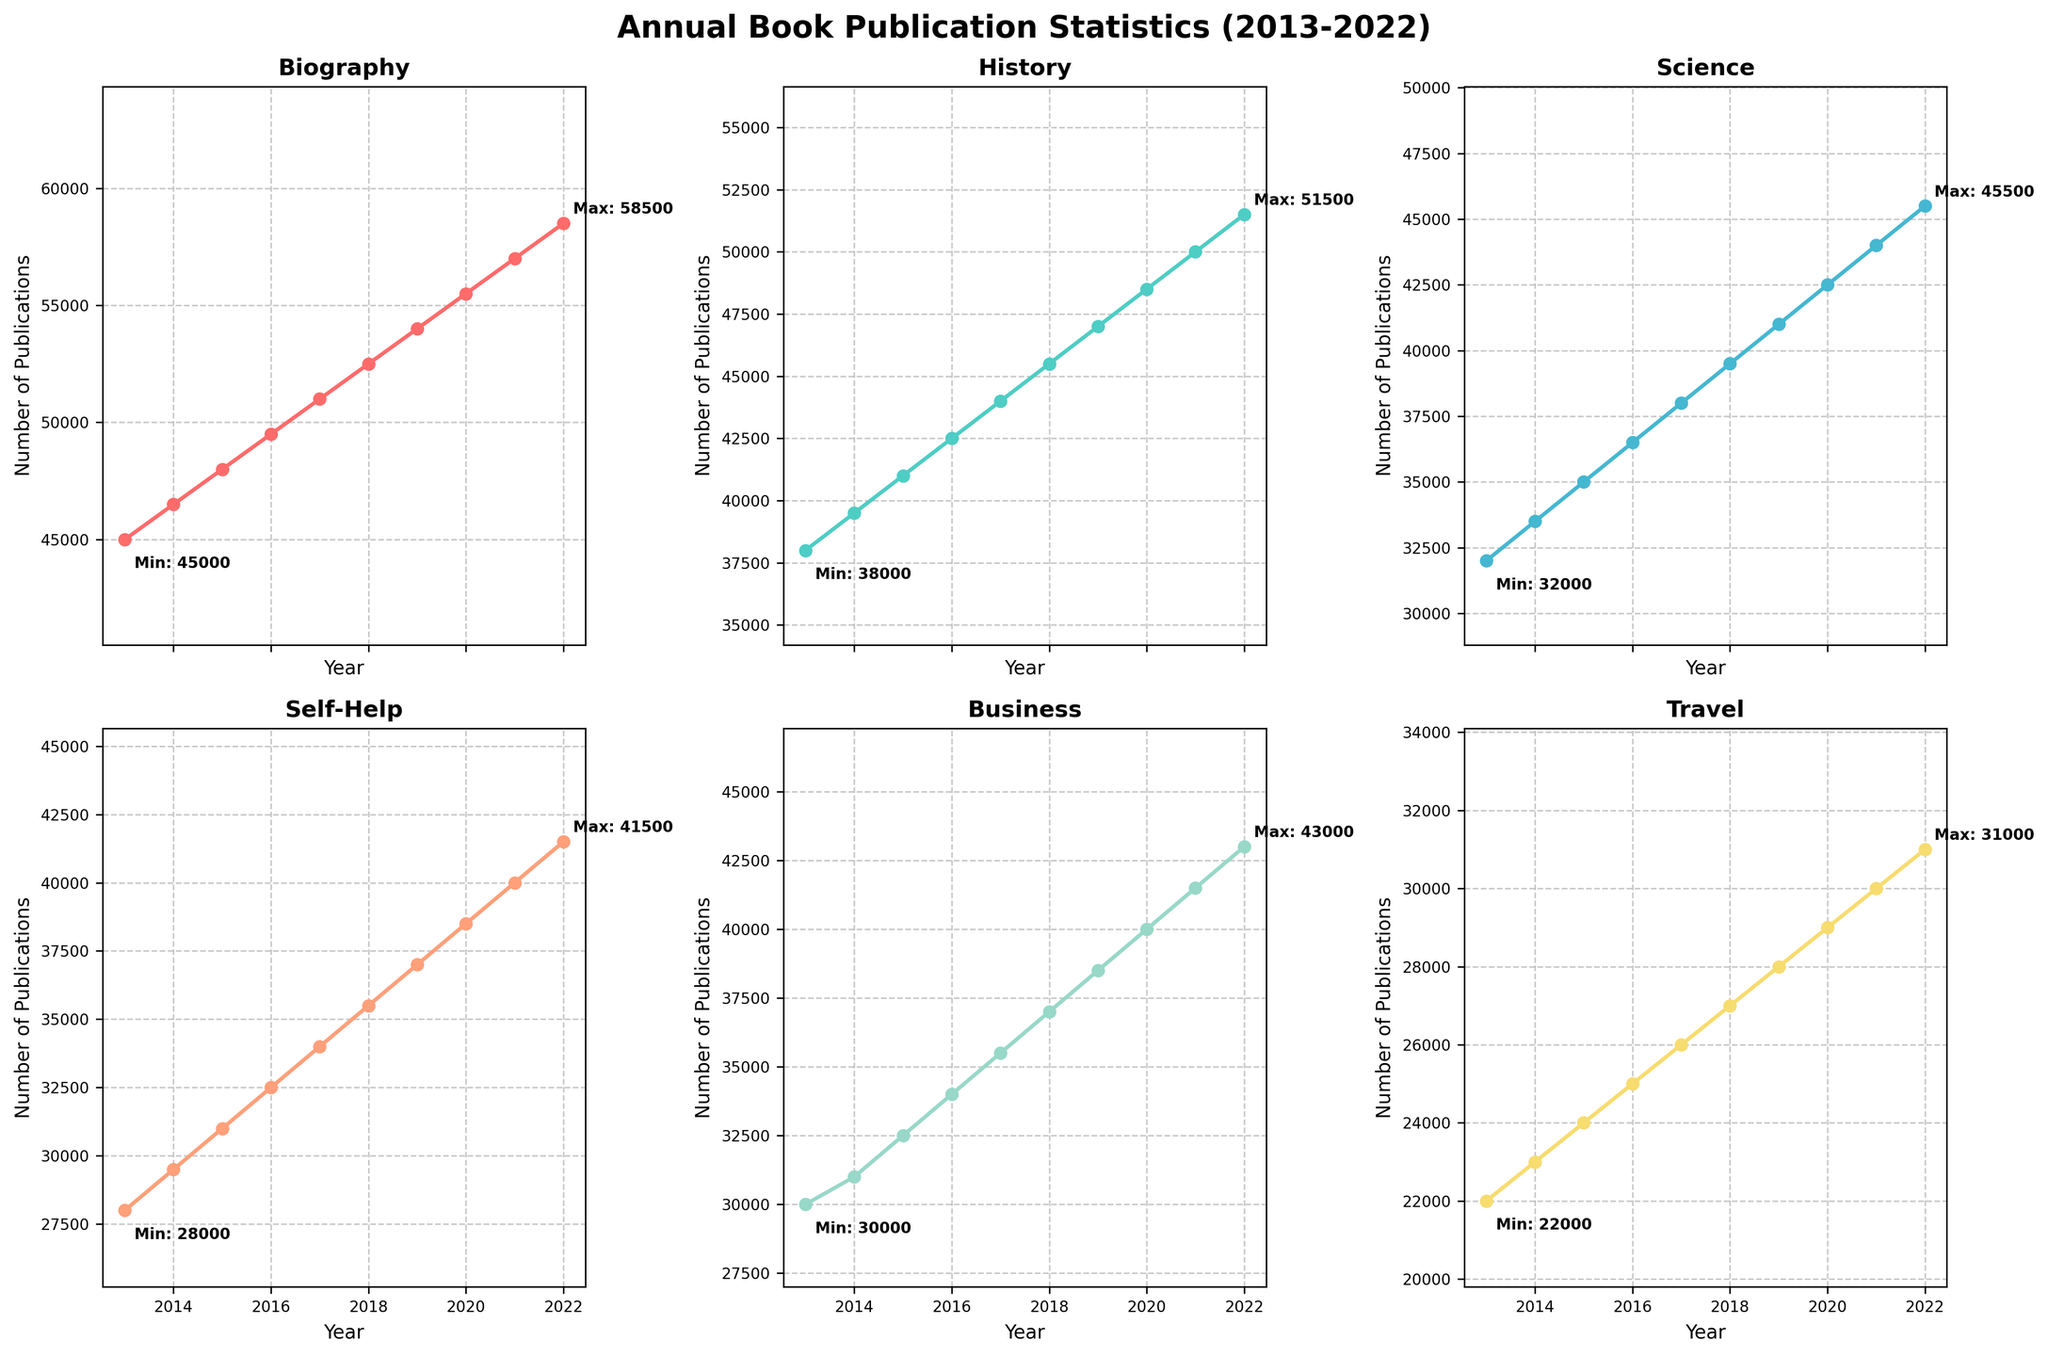What is the overall trend for the number of Biography publications from 2013 to 2022? The number of Biography publications increases each year consistently. Starting from 45,000 in 2013, it rises annually, reaching 58,500 in 2022.
Answer: Increasing trend Which year had the highest number of Science publications? The highest number of Science publications is labeled as "Max: 45500" on the plot for Science, which occurs in the year 2022.
Answer: 2022 By how much did the number of Self-Help publications increase from 2013 to 2019? In 2013, the number of Self-Help publications was 28,000. In 2019, it was 37,000. Therefore, the increase is 37,000 - 28,000.
Answer: 9,000 What is the minimum number of Business publications and in which year did it occur? The minimum number of Business publications is labeled as "Min: 30000" on the plot for Business, which occurs in the year 2013.
Answer: 30,000 in 2013 Among the categories, which saw the minimal increase in publications over the decade? By plotting or checking the change from 2013 to 2022 for each category, the Travel category had the smallest increase from 22,000 in 2013 to 31,000 in 2022, an increase of 9,000.
Answer: Travel Which category had the steepest growth rate between 2013 and 2014? By examining the initial increments, the Biography category grew from 45,000 to 46,500, an increase of 1,500, which is the largest change among all categories in that year span.
Answer: Biography How does the number of History publications in 2019 compare to that in 2015? In 2015, the number of History publications was 41,000 and in 2019, it was 47,000. So, the number increased from 41,000 to 47,000.
Answer: It increased by 6,000 Which category had the continuous highest annual publication from 2013 through 2022? By examining each plot, the Biography category consistently shows the highest annual publication numbers for each year.
Answer: Biography What is the average number of Science publications over the decade? Summing up the yearly numbers for the Science category and dividing by 10: (32,000 + 33,500 + 35,000 + 36,500 + 38,000 + 39,500 + 41,000 + 42,500 + 44,000 + 45,500) / 10 = 39,000.
Answer: 39,000 